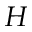Convert formula to latex. <formula><loc_0><loc_0><loc_500><loc_500>H</formula> 